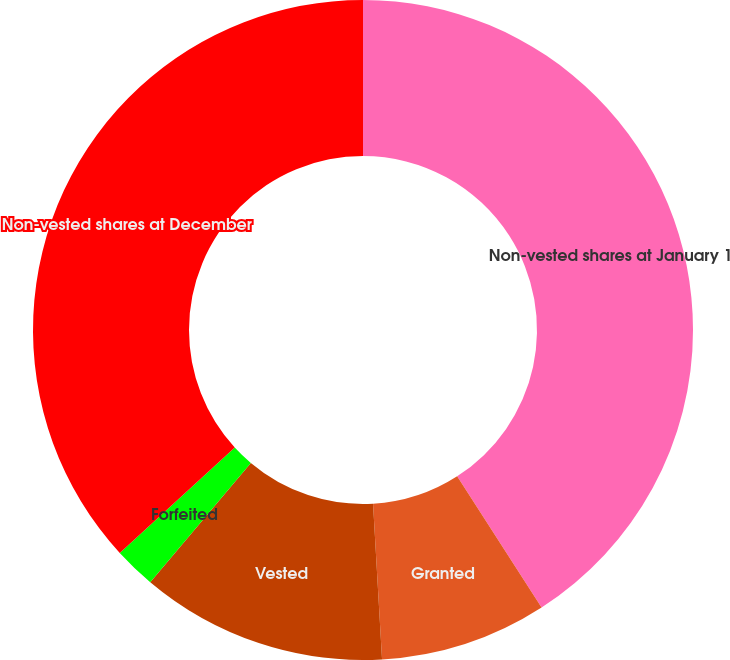<chart> <loc_0><loc_0><loc_500><loc_500><pie_chart><fcel>Non-vested shares at January 1<fcel>Granted<fcel>Vested<fcel>Forfeited<fcel>Non-vested shares at December<nl><fcel>40.9%<fcel>8.18%<fcel>12.07%<fcel>2.04%<fcel>36.81%<nl></chart> 